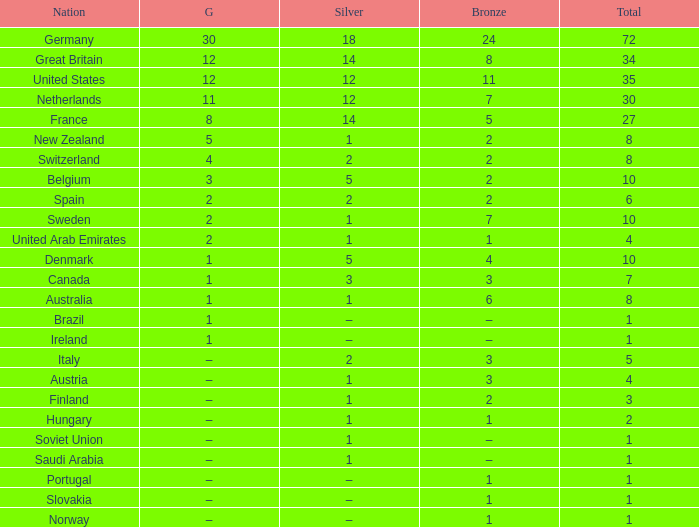What is Gold, when Silver is 5, and when Nation is Belgium? 3.0. Parse the full table. {'header': ['Nation', 'G', 'Silver', 'Bronze', 'Total'], 'rows': [['Germany', '30', '18', '24', '72'], ['Great Britain', '12', '14', '8', '34'], ['United States', '12', '12', '11', '35'], ['Netherlands', '11', '12', '7', '30'], ['France', '8', '14', '5', '27'], ['New Zealand', '5', '1', '2', '8'], ['Switzerland', '4', '2', '2', '8'], ['Belgium', '3', '5', '2', '10'], ['Spain', '2', '2', '2', '6'], ['Sweden', '2', '1', '7', '10'], ['United Arab Emirates', '2', '1', '1', '4'], ['Denmark', '1', '5', '4', '10'], ['Canada', '1', '3', '3', '7'], ['Australia', '1', '1', '6', '8'], ['Brazil', '1', '–', '–', '1'], ['Ireland', '1', '–', '–', '1'], ['Italy', '–', '2', '3', '5'], ['Austria', '–', '1', '3', '4'], ['Finland', '–', '1', '2', '3'], ['Hungary', '–', '1', '1', '2'], ['Soviet Union', '–', '1', '–', '1'], ['Saudi Arabia', '–', '1', '–', '1'], ['Portugal', '–', '–', '1', '1'], ['Slovakia', '–', '–', '1', '1'], ['Norway', '–', '–', '1', '1']]} 